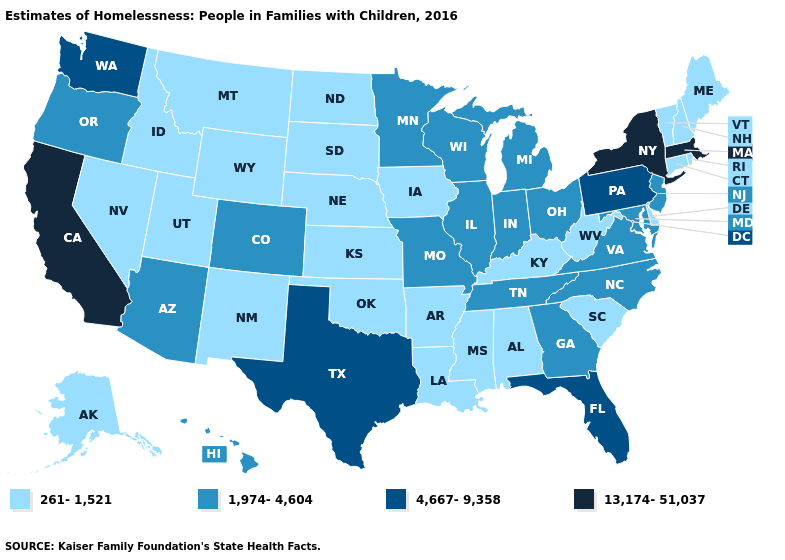Does Wyoming have the same value as Idaho?
Quick response, please. Yes. Name the states that have a value in the range 261-1,521?
Short answer required. Alabama, Alaska, Arkansas, Connecticut, Delaware, Idaho, Iowa, Kansas, Kentucky, Louisiana, Maine, Mississippi, Montana, Nebraska, Nevada, New Hampshire, New Mexico, North Dakota, Oklahoma, Rhode Island, South Carolina, South Dakota, Utah, Vermont, West Virginia, Wyoming. Which states have the lowest value in the USA?
Keep it brief. Alabama, Alaska, Arkansas, Connecticut, Delaware, Idaho, Iowa, Kansas, Kentucky, Louisiana, Maine, Mississippi, Montana, Nebraska, Nevada, New Hampshire, New Mexico, North Dakota, Oklahoma, Rhode Island, South Carolina, South Dakota, Utah, Vermont, West Virginia, Wyoming. Does New Jersey have a higher value than South Dakota?
Keep it brief. Yes. Does the map have missing data?
Concise answer only. No. Among the states that border New Jersey , which have the lowest value?
Answer briefly. Delaware. What is the value of Florida?
Short answer required. 4,667-9,358. Does the map have missing data?
Quick response, please. No. What is the value of Virginia?
Give a very brief answer. 1,974-4,604. Does South Carolina have the highest value in the South?
Concise answer only. No. Does Arizona have a lower value than Minnesota?
Answer briefly. No. Name the states that have a value in the range 13,174-51,037?
Keep it brief. California, Massachusetts, New York. Name the states that have a value in the range 261-1,521?
Answer briefly. Alabama, Alaska, Arkansas, Connecticut, Delaware, Idaho, Iowa, Kansas, Kentucky, Louisiana, Maine, Mississippi, Montana, Nebraska, Nevada, New Hampshire, New Mexico, North Dakota, Oklahoma, Rhode Island, South Carolina, South Dakota, Utah, Vermont, West Virginia, Wyoming. What is the value of Wisconsin?
Concise answer only. 1,974-4,604. Name the states that have a value in the range 261-1,521?
Write a very short answer. Alabama, Alaska, Arkansas, Connecticut, Delaware, Idaho, Iowa, Kansas, Kentucky, Louisiana, Maine, Mississippi, Montana, Nebraska, Nevada, New Hampshire, New Mexico, North Dakota, Oklahoma, Rhode Island, South Carolina, South Dakota, Utah, Vermont, West Virginia, Wyoming. 